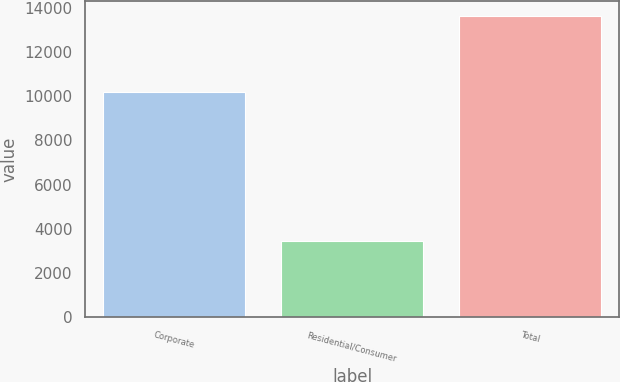Convert chart to OTSL. <chart><loc_0><loc_0><loc_500><loc_500><bar_chart><fcel>Corporate<fcel>Residential/Consumer<fcel>Total<nl><fcel>10169<fcel>3447<fcel>13616<nl></chart> 